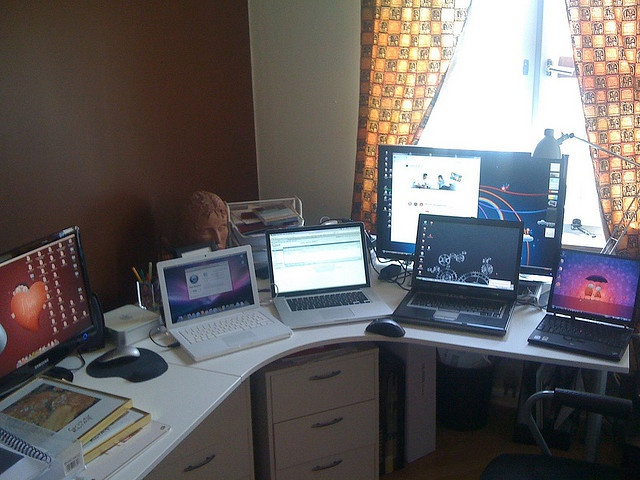Describe the objects in this image and their specific colors. I can see tv in black, white, gray, and blue tones, tv in black, maroon, gray, and brown tones, laptop in black, blue, and navy tones, laptop in black, white, gray, darkgray, and darkblue tones, and laptop in black, darkgray, gray, and navy tones in this image. 